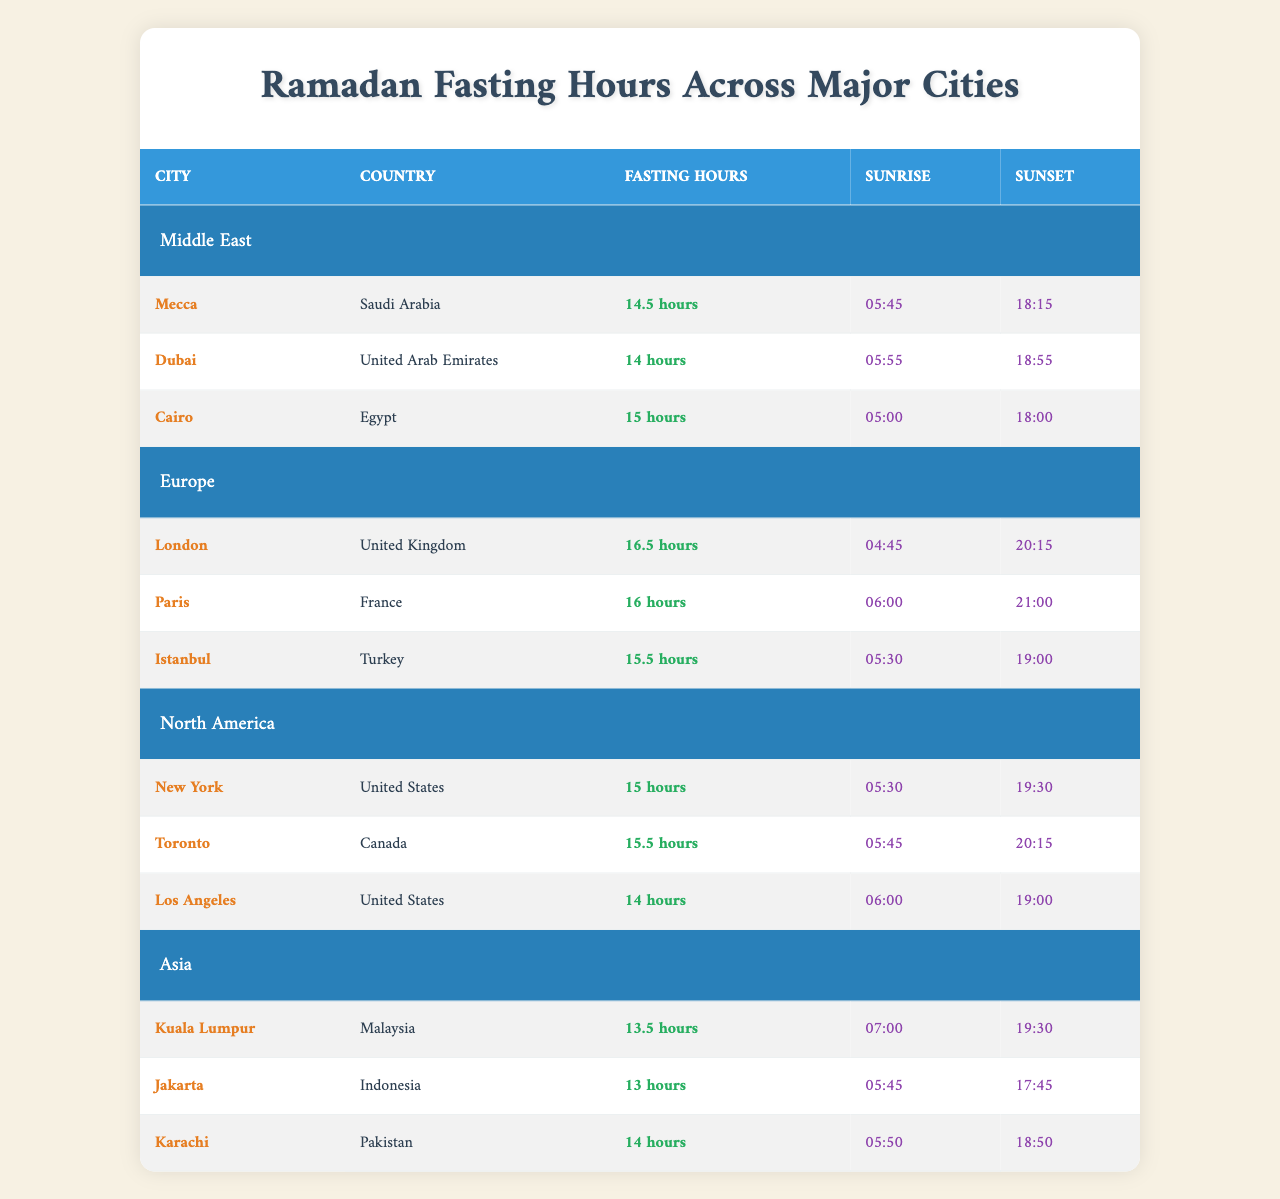What are the fasting hours in Mecca? The table shows that Mecca has fasting hours of 14.5.
Answer: 14.5 hours Which city has the longest fasting hours? London has the longest fasting hours listed in the table, at 16.5 hours.
Answer: London What is the sunset time in Cairo? According to the table, the sunset time in Cairo is 18:00.
Answer: 18:00 How many hours of fasting does Dubai have compared to Karachi? Dubai has 14 hours of fasting, while Karachi has 14 hours as well, so there is no difference.
Answer: No difference What is the average fasting hour duration for cities in Europe? Adding the fasting hours for London (16.5), Paris (16), and Istanbul (15.5) gives us a total of 48 hours. Dividing by 3, we get an average of 16 hours.
Answer: 16 hours Is the fasting duration longer in New York or Los Angeles? The table indicates that New York has 15 hours fasting while Los Angeles has 14 hours, so New York has a longer fasting duration.
Answer: Yes, New York Calculate the total fasting hours for all cities in the Middle East listed. Adding the fasting hours: Mecca (14.5) + Dubai (14) + Cairo (15) = 43.5 hours.
Answer: 43.5 hours How does the sunrise time in Jakarta compare to Kuala Lumpur? Jakarta has a sunrise time of 05:45, while Kuala Lumpur has a later sunrise at 07:00, meaning Jakarta's sunrise is earlier.
Answer: Earlier Which region has the city with the latest sunset? The city with the latest sunset is Paris, at 21:00, making Europe the region with the latest sunset.
Answer: Europe Are the fasting hours in Karachi longer than those in Dubai? Karachi has 14 hours of fasting and Dubai has 14 hours as well, so they are equal, not longer.
Answer: No 